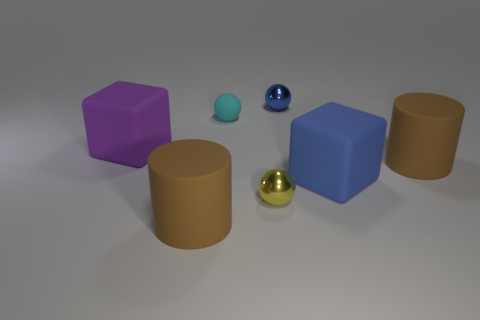There is a metallic object that is right of the small yellow sphere; is its shape the same as the tiny matte thing?
Keep it short and to the point. Yes. How many blue things are either spheres or cubes?
Provide a short and direct response. 2. There is another thing that is the same shape as the large purple rubber object; what is its material?
Ensure brevity in your answer.  Rubber. What shape is the large brown thing that is to the left of the tiny cyan sphere?
Provide a short and direct response. Cylinder. Is there a large block made of the same material as the small blue ball?
Make the answer very short. No. Do the matte ball and the purple rubber cube have the same size?
Your response must be concise. No. What number of cylinders are purple things or large things?
Your answer should be very brief. 2. How many other objects are the same shape as the yellow object?
Make the answer very short. 2. Are there more spheres that are left of the purple thing than large brown matte cylinders in front of the blue matte object?
Make the answer very short. No. There is a large rubber cylinder that is behind the yellow thing; is its color the same as the small matte object?
Your answer should be very brief. No. 